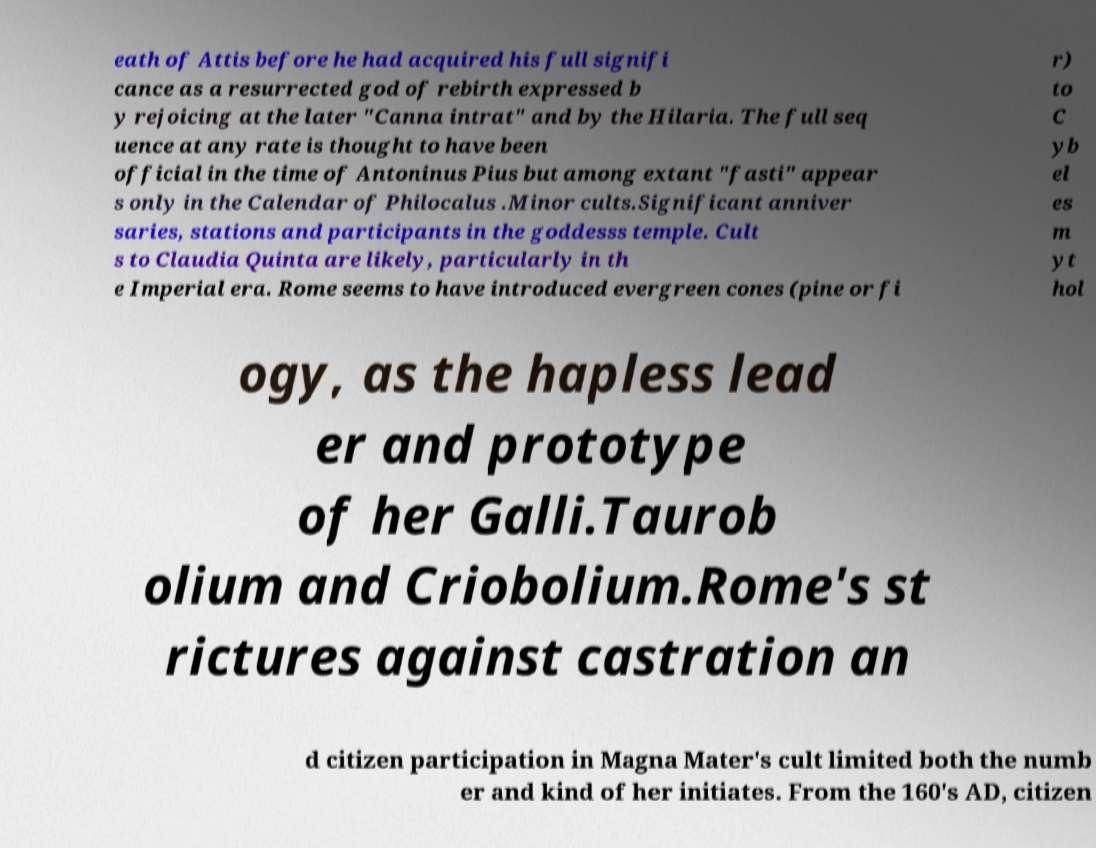For documentation purposes, I need the text within this image transcribed. Could you provide that? eath of Attis before he had acquired his full signifi cance as a resurrected god of rebirth expressed b y rejoicing at the later "Canna intrat" and by the Hilaria. The full seq uence at any rate is thought to have been official in the time of Antoninus Pius but among extant "fasti" appear s only in the Calendar of Philocalus .Minor cults.Significant anniver saries, stations and participants in the goddesss temple. Cult s to Claudia Quinta are likely, particularly in th e Imperial era. Rome seems to have introduced evergreen cones (pine or fi r) to C yb el es m yt hol ogy, as the hapless lead er and prototype of her Galli.Taurob olium and Criobolium.Rome's st rictures against castration an d citizen participation in Magna Mater's cult limited both the numb er and kind of her initiates. From the 160's AD, citizen 